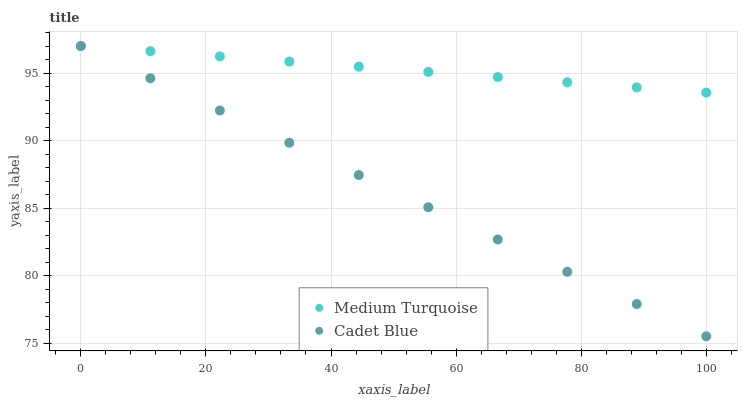Does Cadet Blue have the minimum area under the curve?
Answer yes or no. Yes. Does Medium Turquoise have the maximum area under the curve?
Answer yes or no. Yes. Does Medium Turquoise have the minimum area under the curve?
Answer yes or no. No. Is Medium Turquoise the smoothest?
Answer yes or no. Yes. Is Cadet Blue the roughest?
Answer yes or no. Yes. Is Medium Turquoise the roughest?
Answer yes or no. No. Does Cadet Blue have the lowest value?
Answer yes or no. Yes. Does Medium Turquoise have the lowest value?
Answer yes or no. No. Does Medium Turquoise have the highest value?
Answer yes or no. Yes. Does Medium Turquoise intersect Cadet Blue?
Answer yes or no. Yes. Is Medium Turquoise less than Cadet Blue?
Answer yes or no. No. Is Medium Turquoise greater than Cadet Blue?
Answer yes or no. No. 